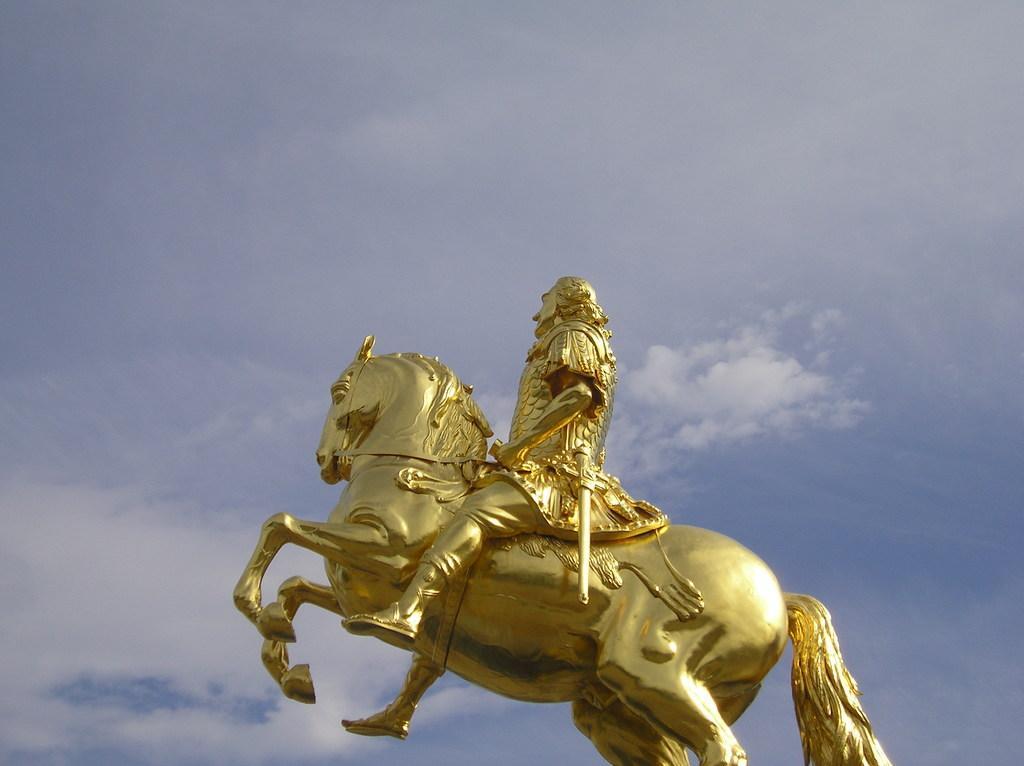Describe this image in one or two sentences. This picture is clicked outside. In the center we can see the sculpture of a person sitting on the sculpture of a horse. In the background we can see the sky and the clouds and the sculpture of an object. 